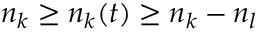Convert formula to latex. <formula><loc_0><loc_0><loc_500><loc_500>n _ { k } \geq n _ { k } ( t ) \geq n _ { k } - n _ { l }</formula> 